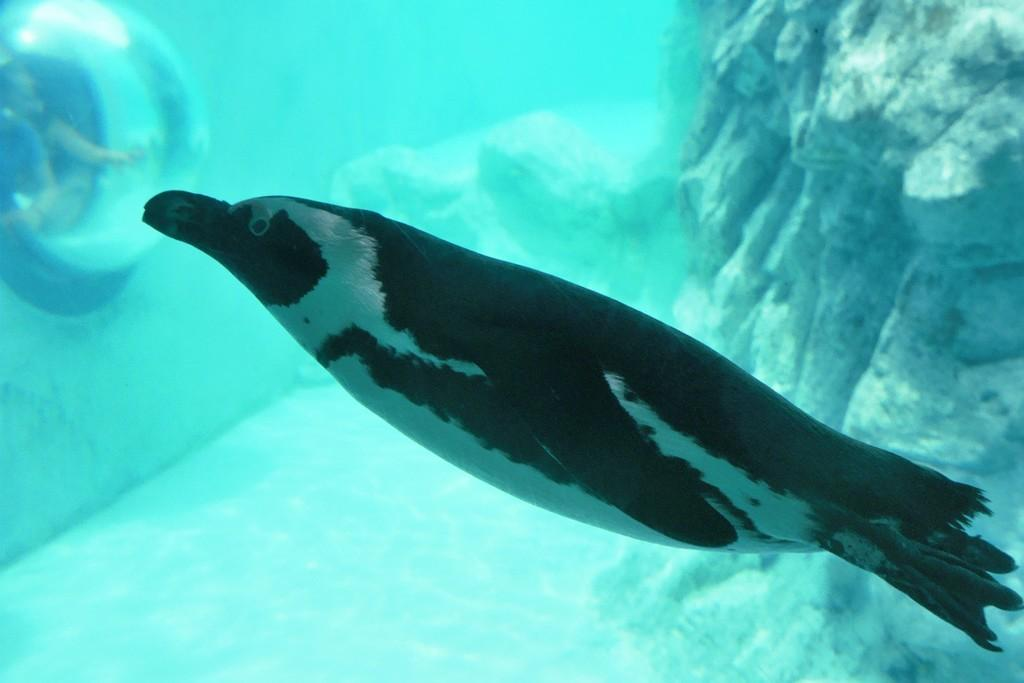What is the animal doing in the water? The fact provided does not specify what the animal is doing in the water. What can be seen in the background of the image? There is a rock in the background of the image. What type of treatment is the animal receiving for its blood condition in the image? There is no indication in the image that the animal is receiving any treatment or has a blood condition. 